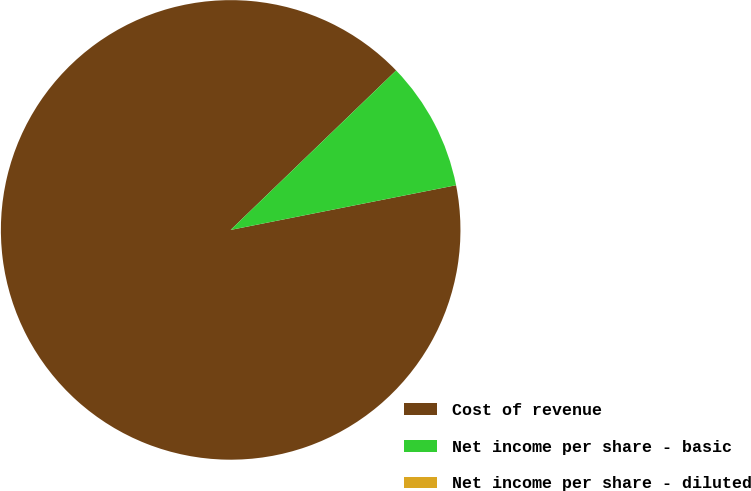Convert chart. <chart><loc_0><loc_0><loc_500><loc_500><pie_chart><fcel>Cost of revenue<fcel>Net income per share - basic<fcel>Net income per share - diluted<nl><fcel>90.91%<fcel>9.09%<fcel>0.0%<nl></chart> 